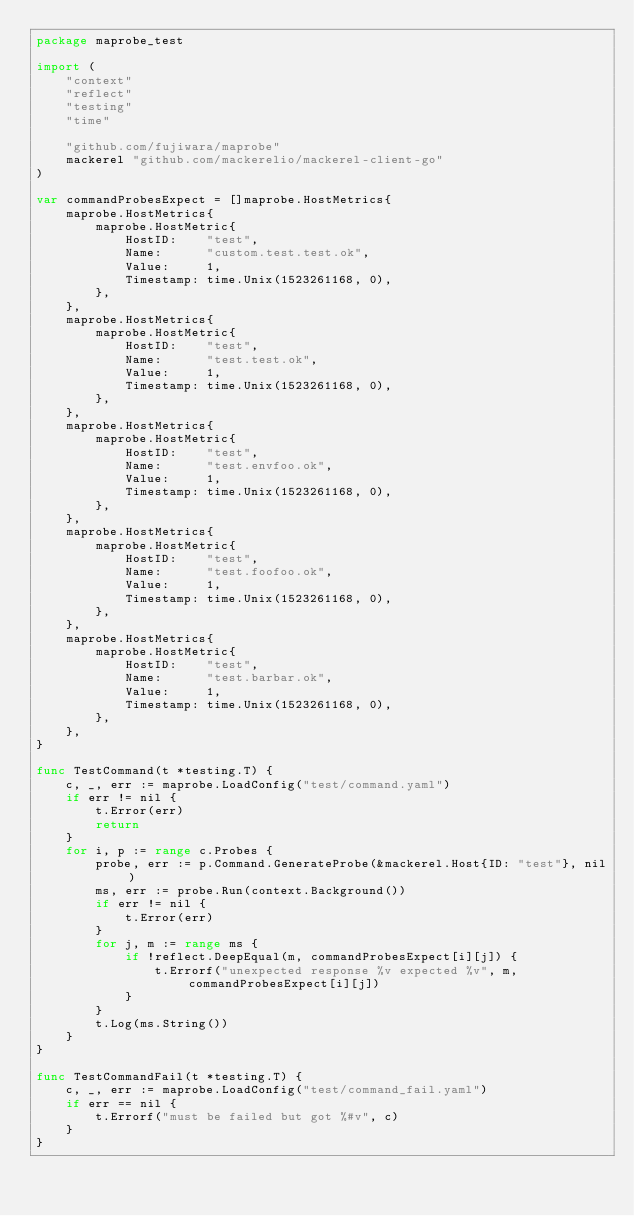<code> <loc_0><loc_0><loc_500><loc_500><_Go_>package maprobe_test

import (
	"context"
	"reflect"
	"testing"
	"time"

	"github.com/fujiwara/maprobe"
	mackerel "github.com/mackerelio/mackerel-client-go"
)

var commandProbesExpect = []maprobe.HostMetrics{
	maprobe.HostMetrics{
		maprobe.HostMetric{
			HostID:    "test",
			Name:      "custom.test.test.ok",
			Value:     1,
			Timestamp: time.Unix(1523261168, 0),
		},
	},
	maprobe.HostMetrics{
		maprobe.HostMetric{
			HostID:    "test",
			Name:      "test.test.ok",
			Value:     1,
			Timestamp: time.Unix(1523261168, 0),
		},
	},
	maprobe.HostMetrics{
		maprobe.HostMetric{
			HostID:    "test",
			Name:      "test.envfoo.ok",
			Value:     1,
			Timestamp: time.Unix(1523261168, 0),
		},
	},
	maprobe.HostMetrics{
		maprobe.HostMetric{
			HostID:    "test",
			Name:      "test.foofoo.ok",
			Value:     1,
			Timestamp: time.Unix(1523261168, 0),
		},
	},
	maprobe.HostMetrics{
		maprobe.HostMetric{
			HostID:    "test",
			Name:      "test.barbar.ok",
			Value:     1,
			Timestamp: time.Unix(1523261168, 0),
		},
	},
}

func TestCommand(t *testing.T) {
	c, _, err := maprobe.LoadConfig("test/command.yaml")
	if err != nil {
		t.Error(err)
		return
	}
	for i, p := range c.Probes {
		probe, err := p.Command.GenerateProbe(&mackerel.Host{ID: "test"}, nil)
		ms, err := probe.Run(context.Background())
		if err != nil {
			t.Error(err)
		}
		for j, m := range ms {
			if !reflect.DeepEqual(m, commandProbesExpect[i][j]) {
				t.Errorf("unexpected response %v expected %v", m, commandProbesExpect[i][j])
			}
		}
		t.Log(ms.String())
	}
}

func TestCommandFail(t *testing.T) {
	c, _, err := maprobe.LoadConfig("test/command_fail.yaml")
	if err == nil {
		t.Errorf("must be failed but got %#v", c)
	}
}
</code> 